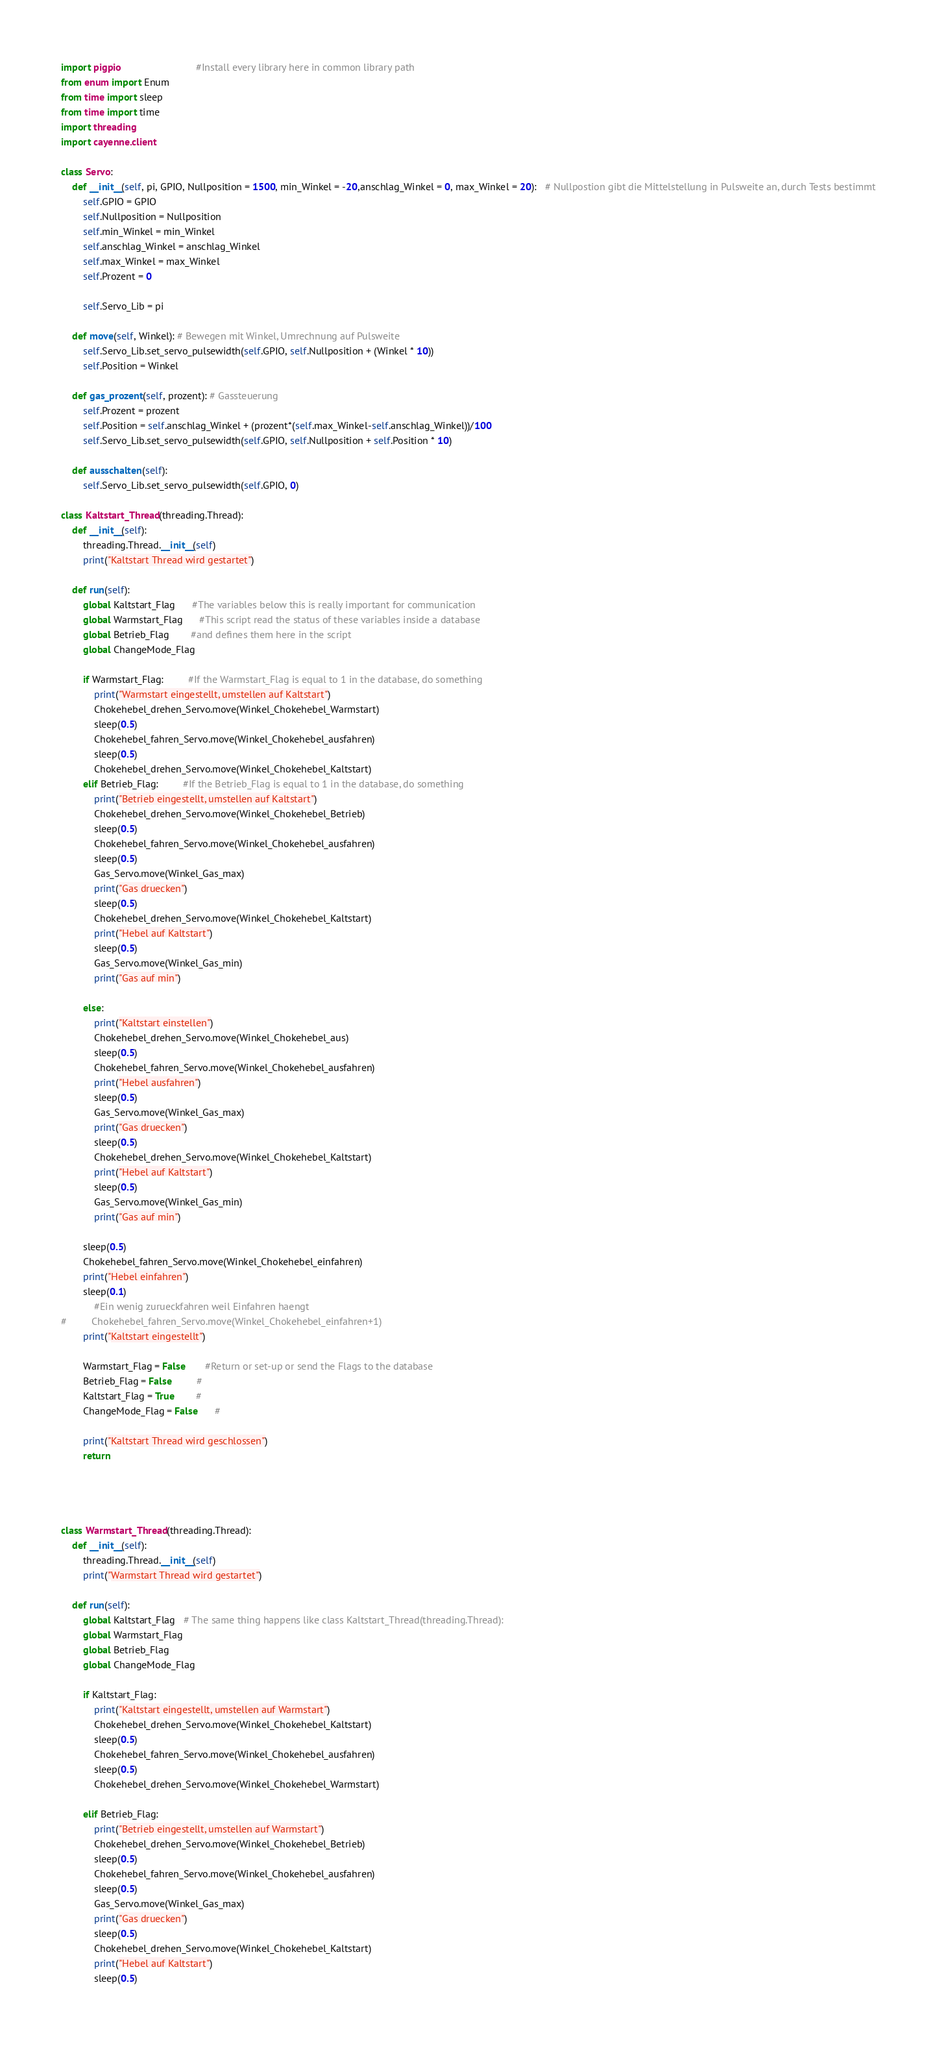<code> <loc_0><loc_0><loc_500><loc_500><_Python_>import pigpio                           #Install every library here in common library path
from enum import Enum
from time import sleep
from time import time
import threading
import cayenne.client

class Servo:
    def __init__(self, pi, GPIO, Nullposition = 1500, min_Winkel = -20,anschlag_Winkel = 0, max_Winkel = 20):   # Nullpostion gibt die Mittelstellung in Pulsweite an, durch Tests bestimmt
        self.GPIO = GPIO
        self.Nullposition = Nullposition
        self.min_Winkel = min_Winkel
        self.anschlag_Winkel = anschlag_Winkel
        self.max_Winkel = max_Winkel
        self.Prozent = 0
        
        self.Servo_Lib = pi
        
    def move(self, Winkel): # Bewegen mit Winkel, Umrechnung auf Pulsweite
        self.Servo_Lib.set_servo_pulsewidth(self.GPIO, self.Nullposition + (Winkel * 10))
        self.Position = Winkel
        
    def gas_prozent(self, prozent): # Gassteuerung
        self.Prozent = prozent
        self.Position = self.anschlag_Winkel + (prozent*(self.max_Winkel-self.anschlag_Winkel))/100
        self.Servo_Lib.set_servo_pulsewidth(self.GPIO, self.Nullposition + self.Position * 10)
       
    def ausschalten(self):
        self.Servo_Lib.set_servo_pulsewidth(self.GPIO, 0)
       
class Kaltstart_Thread(threading.Thread):
    def __init__(self):
        threading.Thread.__init__(self)
        print("Kaltstart Thread wird gestartet")
        
    def run(self):
        global Kaltstart_Flag      #The variables below this is really important for communication
        global Warmstart_Flag      #This script read the status of these variables inside a database
        global Betrieb_Flag        #and defines them here in the script
        global ChangeMode_Flag
        
        if Warmstart_Flag:         #If the Warmstart_Flag is equal to 1 in the database, do something
            print("Warmstart eingestellt, umstellen auf Kaltstart")
            Chokehebel_drehen_Servo.move(Winkel_Chokehebel_Warmstart)
            sleep(0.5)
            Chokehebel_fahren_Servo.move(Winkel_Chokehebel_ausfahren)
            sleep(0.5)
            Chokehebel_drehen_Servo.move(Winkel_Chokehebel_Kaltstart)
        elif Betrieb_Flag:         #If the Betrieb_Flag is equal to 1 in the database, do something
            print("Betrieb eingestellt, umstellen auf Kaltstart")
            Chokehebel_drehen_Servo.move(Winkel_Chokehebel_Betrieb)
            sleep(0.5)
            Chokehebel_fahren_Servo.move(Winkel_Chokehebel_ausfahren)
            sleep(0.5)
            Gas_Servo.move(Winkel_Gas_max)
            print("Gas druecken")
            sleep(0.5)
            Chokehebel_drehen_Servo.move(Winkel_Chokehebel_Kaltstart)
            print("Hebel auf Kaltstart")
            sleep(0.5)
            Gas_Servo.move(Winkel_Gas_min)
            print("Gas auf min")
            
        else:
            print("Kaltstart einstellen")
            Chokehebel_drehen_Servo.move(Winkel_Chokehebel_aus)
            sleep(0.5)
            Chokehebel_fahren_Servo.move(Winkel_Chokehebel_ausfahren)
            print("Hebel ausfahren")
            sleep(0.5)
            Gas_Servo.move(Winkel_Gas_max)
            print("Gas druecken")
            sleep(0.5)
            Chokehebel_drehen_Servo.move(Winkel_Chokehebel_Kaltstart)
            print("Hebel auf Kaltstart")
            sleep(0.5)
            Gas_Servo.move(Winkel_Gas_min)
            print("Gas auf min")

        sleep(0.5)
        Chokehebel_fahren_Servo.move(Winkel_Chokehebel_einfahren)
        print("Hebel einfahren")
        sleep(0.1)
            #Ein wenig zurueckfahren weil Einfahren haengt
#         Chokehebel_fahren_Servo.move(Winkel_Chokehebel_einfahren+1)
        print("Kaltstart eingestellt")
        
        Warmstart_Flag = False       #Return or set-up or send the Flags to the database
        Betrieb_Flag = False         #
        Kaltstart_Flag = True        #
        ChangeMode_Flag = False      #
        
        print("Kaltstart Thread wird geschlossen")
        return
        
        
        
       
class Warmstart_Thread(threading.Thread):
    def __init__(self):
        threading.Thread.__init__(self)
        print("Warmstart Thread wird gestartet")
        
    def run(self):
        global Kaltstart_Flag   # The same thing happens like class Kaltstart_Thread(threading.Thread):
        global Warmstart_Flag
        global Betrieb_Flag
        global ChangeMode_Flag
        
        if Kaltstart_Flag:
            print("Kaltstart eingestellt, umstellen auf Warmstart")
            Chokehebel_drehen_Servo.move(Winkel_Chokehebel_Kaltstart)
            sleep(0.5)
            Chokehebel_fahren_Servo.move(Winkel_Chokehebel_ausfahren)
            sleep(0.5)
            Chokehebel_drehen_Servo.move(Winkel_Chokehebel_Warmstart)
        
        elif Betrieb_Flag:
            print("Betrieb eingestellt, umstellen auf Warmstart")
            Chokehebel_drehen_Servo.move(Winkel_Chokehebel_Betrieb)
            sleep(0.5)
            Chokehebel_fahren_Servo.move(Winkel_Chokehebel_ausfahren)
            sleep(0.5)
            Gas_Servo.move(Winkel_Gas_max)
            print("Gas druecken")
            sleep(0.5)
            Chokehebel_drehen_Servo.move(Winkel_Chokehebel_Kaltstart)
            print("Hebel auf Kaltstart")
            sleep(0.5)</code> 